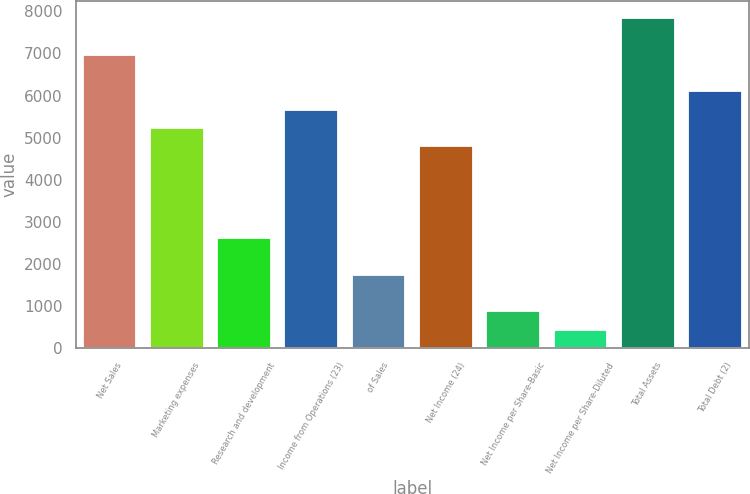<chart> <loc_0><loc_0><loc_500><loc_500><bar_chart><fcel>Net Sales<fcel>Marketing expenses<fcel>Research and development<fcel>Income from Operations (23)<fcel>of Sales<fcel>Net Income (24)<fcel>Net Income per Share-Basic<fcel>Net Income per Share-Diluted<fcel>Total Assets<fcel>Total Debt (2)<nl><fcel>6974.38<fcel>5230.94<fcel>2615.78<fcel>5666.8<fcel>1744.06<fcel>4795.08<fcel>872.34<fcel>436.48<fcel>7846.1<fcel>6102.66<nl></chart> 